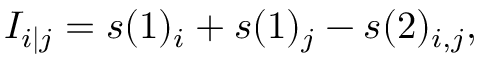<formula> <loc_0><loc_0><loc_500><loc_500>I _ { i | j } = s ( 1 ) _ { i } + s ( 1 ) _ { j } - s ( 2 ) _ { i , j } ,</formula> 